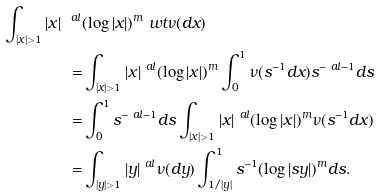<formula> <loc_0><loc_0><loc_500><loc_500>\int _ { | x | > 1 } | x | ^ { \ a l } & ( \log | x | ) ^ { m } \ w t \nu ( d x ) \\ = & \int _ { | x | > 1 } | x | ^ { \ a l } ( \log | x | ) ^ { m } \int ^ { 1 } _ { 0 } \nu ( s ^ { - 1 } d x ) s ^ { - \ a l - 1 } d s \\ = & \int ^ { 1 } _ { 0 } s ^ { - \ a l - 1 } d s \int _ { | x | > 1 } | x | ^ { \ a l } ( \log | x | ) ^ { m } \nu ( s ^ { - 1 } d x ) \\ = & \int _ { | y | > 1 } | y | ^ { \ a l } \nu ( d y ) \int ^ { 1 } _ { 1 / | y | } s ^ { - 1 } ( \log | s y | ) ^ { m } d s .</formula> 